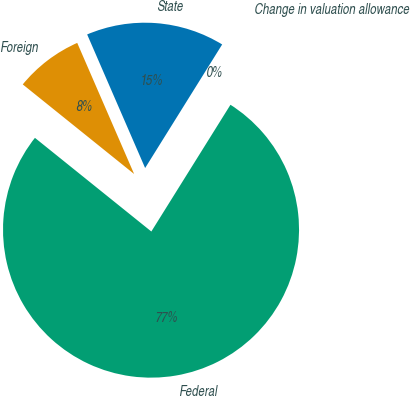<chart> <loc_0><loc_0><loc_500><loc_500><pie_chart><fcel>State<fcel>Foreign<fcel>Federal<fcel>Change in valuation allowance<nl><fcel>15.39%<fcel>7.7%<fcel>76.9%<fcel>0.01%<nl></chart> 